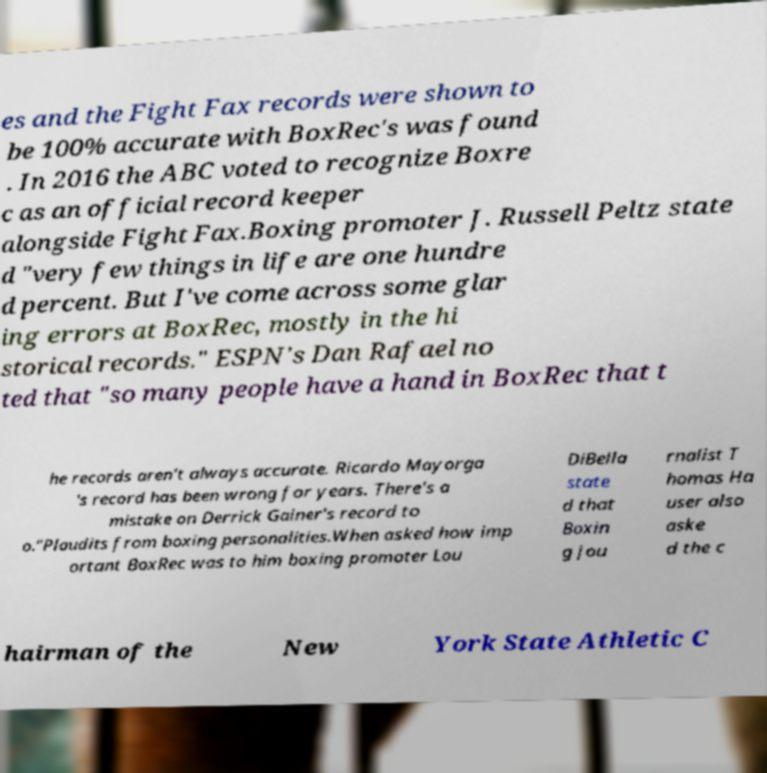There's text embedded in this image that I need extracted. Can you transcribe it verbatim? es and the Fight Fax records were shown to be 100% accurate with BoxRec's was found . In 2016 the ABC voted to recognize Boxre c as an official record keeper alongside Fight Fax.Boxing promoter J. Russell Peltz state d "very few things in life are one hundre d percent. But I've come across some glar ing errors at BoxRec, mostly in the hi storical records." ESPN's Dan Rafael no ted that "so many people have a hand in BoxRec that t he records aren't always accurate. Ricardo Mayorga 's record has been wrong for years. There's a mistake on Derrick Gainer's record to o."Plaudits from boxing personalities.When asked how imp ortant BoxRec was to him boxing promoter Lou DiBella state d that Boxin g jou rnalist T homas Ha user also aske d the c hairman of the New York State Athletic C 